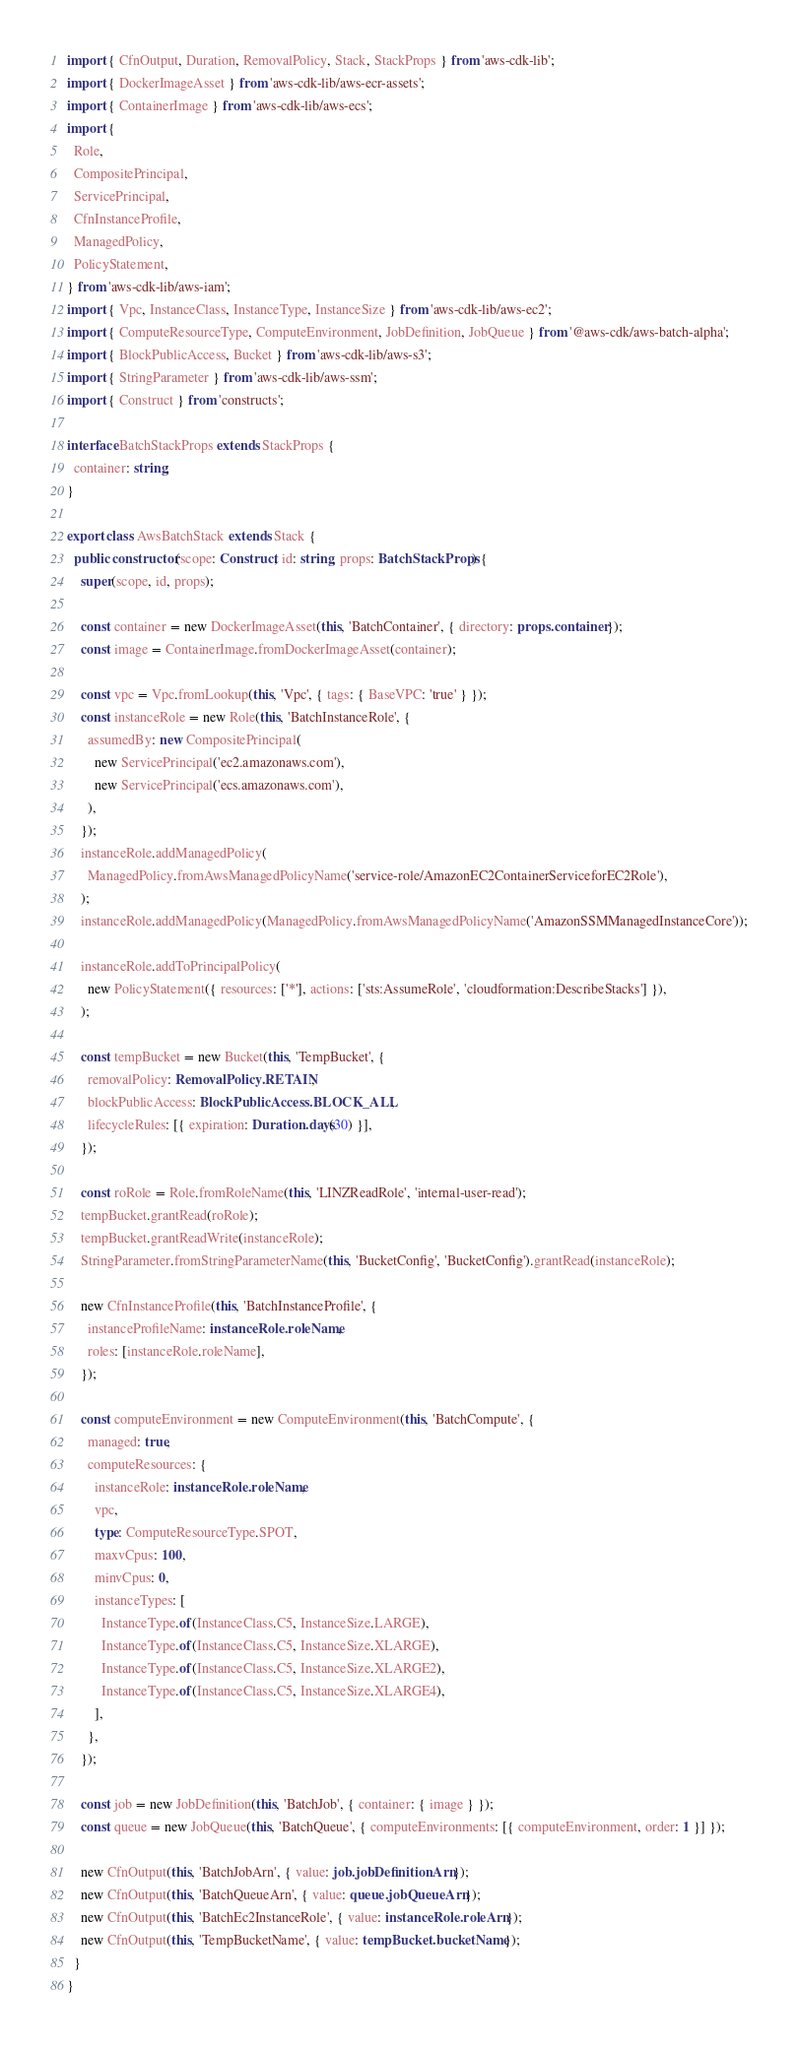Convert code to text. <code><loc_0><loc_0><loc_500><loc_500><_TypeScript_>import { CfnOutput, Duration, RemovalPolicy, Stack, StackProps } from 'aws-cdk-lib';
import { DockerImageAsset } from 'aws-cdk-lib/aws-ecr-assets';
import { ContainerImage } from 'aws-cdk-lib/aws-ecs';
import {
  Role,
  CompositePrincipal,
  ServicePrincipal,
  CfnInstanceProfile,
  ManagedPolicy,
  PolicyStatement,
} from 'aws-cdk-lib/aws-iam';
import { Vpc, InstanceClass, InstanceType, InstanceSize } from 'aws-cdk-lib/aws-ec2';
import { ComputeResourceType, ComputeEnvironment, JobDefinition, JobQueue } from '@aws-cdk/aws-batch-alpha';
import { BlockPublicAccess, Bucket } from 'aws-cdk-lib/aws-s3';
import { StringParameter } from 'aws-cdk-lib/aws-ssm';
import { Construct } from 'constructs';

interface BatchStackProps extends StackProps {
  container: string;
}

export class AwsBatchStack extends Stack {
  public constructor(scope: Construct, id: string, props: BatchStackProps) {
    super(scope, id, props);

    const container = new DockerImageAsset(this, 'BatchContainer', { directory: props.container });
    const image = ContainerImage.fromDockerImageAsset(container);

    const vpc = Vpc.fromLookup(this, 'Vpc', { tags: { BaseVPC: 'true' } });
    const instanceRole = new Role(this, 'BatchInstanceRole', {
      assumedBy: new CompositePrincipal(
        new ServicePrincipal('ec2.amazonaws.com'),
        new ServicePrincipal('ecs.amazonaws.com'),
      ),
    });
    instanceRole.addManagedPolicy(
      ManagedPolicy.fromAwsManagedPolicyName('service-role/AmazonEC2ContainerServiceforEC2Role'),
    );
    instanceRole.addManagedPolicy(ManagedPolicy.fromAwsManagedPolicyName('AmazonSSMManagedInstanceCore'));

    instanceRole.addToPrincipalPolicy(
      new PolicyStatement({ resources: ['*'], actions: ['sts:AssumeRole', 'cloudformation:DescribeStacks'] }),
    );

    const tempBucket = new Bucket(this, 'TempBucket', {
      removalPolicy: RemovalPolicy.RETAIN,
      blockPublicAccess: BlockPublicAccess.BLOCK_ALL,
      lifecycleRules: [{ expiration: Duration.days(30) }],
    });

    const roRole = Role.fromRoleName(this, 'LINZReadRole', 'internal-user-read');
    tempBucket.grantRead(roRole);
    tempBucket.grantReadWrite(instanceRole);
    StringParameter.fromStringParameterName(this, 'BucketConfig', 'BucketConfig').grantRead(instanceRole);

    new CfnInstanceProfile(this, 'BatchInstanceProfile', {
      instanceProfileName: instanceRole.roleName,
      roles: [instanceRole.roleName],
    });

    const computeEnvironment = new ComputeEnvironment(this, 'BatchCompute', {
      managed: true,
      computeResources: {
        instanceRole: instanceRole.roleName,
        vpc,
        type: ComputeResourceType.SPOT,
        maxvCpus: 100,
        minvCpus: 0,
        instanceTypes: [
          InstanceType.of(InstanceClass.C5, InstanceSize.LARGE),
          InstanceType.of(InstanceClass.C5, InstanceSize.XLARGE),
          InstanceType.of(InstanceClass.C5, InstanceSize.XLARGE2),
          InstanceType.of(InstanceClass.C5, InstanceSize.XLARGE4),
        ],
      },
    });

    const job = new JobDefinition(this, 'BatchJob', { container: { image } });
    const queue = new JobQueue(this, 'BatchQueue', { computeEnvironments: [{ computeEnvironment, order: 1 }] });

    new CfnOutput(this, 'BatchJobArn', { value: job.jobDefinitionArn });
    new CfnOutput(this, 'BatchQueueArn', { value: queue.jobQueueArn });
    new CfnOutput(this, 'BatchEc2InstanceRole', { value: instanceRole.roleArn });
    new CfnOutput(this, 'TempBucketName', { value: tempBucket.bucketName });
  }
}
</code> 